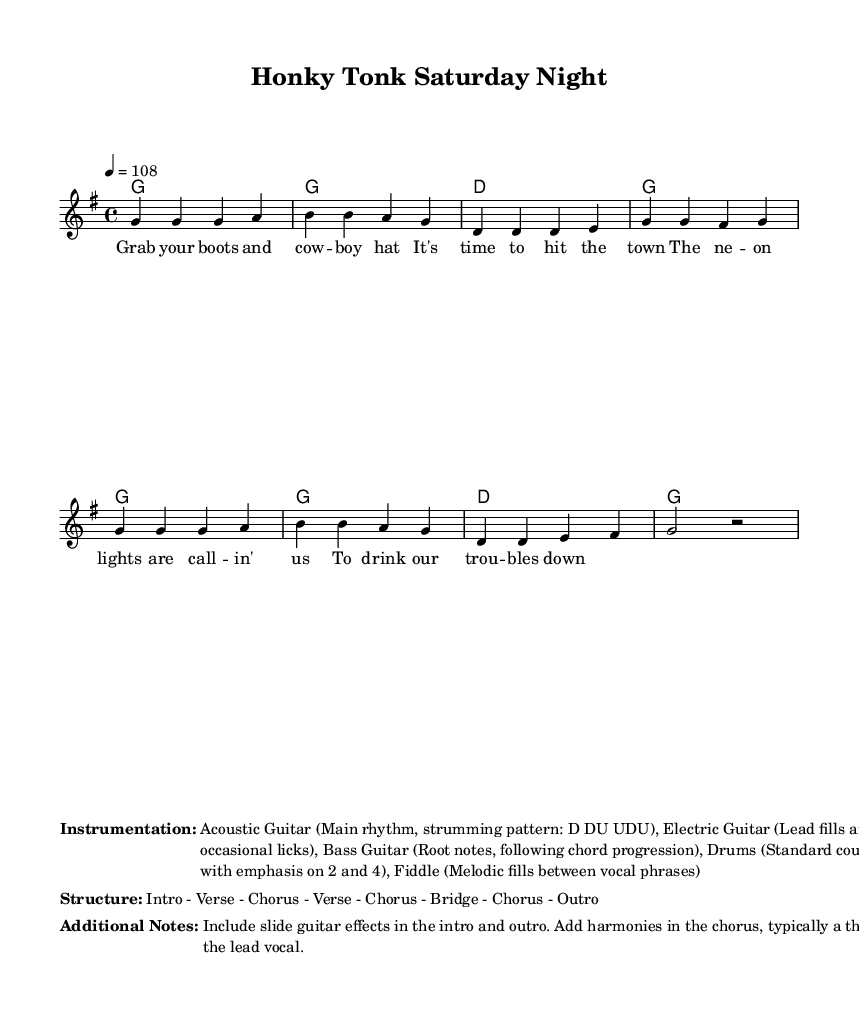What is the key signature of this music? The key signature indicates G major, which has one sharp (F#). This can be identified from the indication in front of the staff.
Answer: G major What is the time signature of this piece? The time signature is 4/4, which means there are four beats in a measure and the quarter note gets one beat. This is indicated at the beginning of the score.
Answer: 4/4 What is the tempo of the piece? The tempo is marked as quarter note equals 108 beats per minute, which provides an indication of the speed at which the music should be played. This is stated at the beginning of the score.
Answer: 108 How many verses does the song contain based on the structure provided? The structure mentions "Verse - Chorus - Verse - Chorus - Bridge - Chorus - Outro", indicating that there are two verses included in the structure.
Answer: 2 What instruments are specified for this piece? The instrumentation includes Acoustic Guitar, Electric Guitar, Bass Guitar, Drums, and Fiddle as described in the detailed notes section.
Answer: Acoustic Guitar, Electric Guitar, Bass Guitar, Drums, Fiddle What unique feature in this country song suggests the inclusion of slide guitar? The additional notes mention the inclusion of slide guitar effects specifically in the intro and outro, which is a characteristic feature of country music that lends to its emotional expression.
Answer: Slide guitar effects What type of vocal harmonies are suggested in the song? The additional notes suggest adding harmonies in the chorus, typically a third above the lead vocal, which is a common practice in country music to enrich the sound.
Answer: A third above 